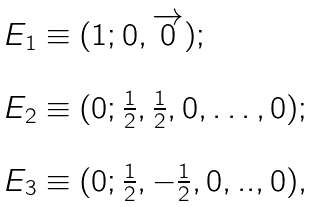Convert formula to latex. <formula><loc_0><loc_0><loc_500><loc_500>\begin{array} { l } E _ { 1 } \equiv ( 1 ; 0 , \overrightarrow { 0 } ) ; \\ \\ E _ { 2 } \equiv ( 0 ; \frac { 1 } { 2 } , \frac { 1 } { 2 } , 0 , \dots , 0 ) ; \\ \\ E _ { 3 } \equiv ( 0 ; \frac { 1 } { 2 } , - \frac { 1 } { 2 } , 0 , . . , 0 ) , \end{array}</formula> 